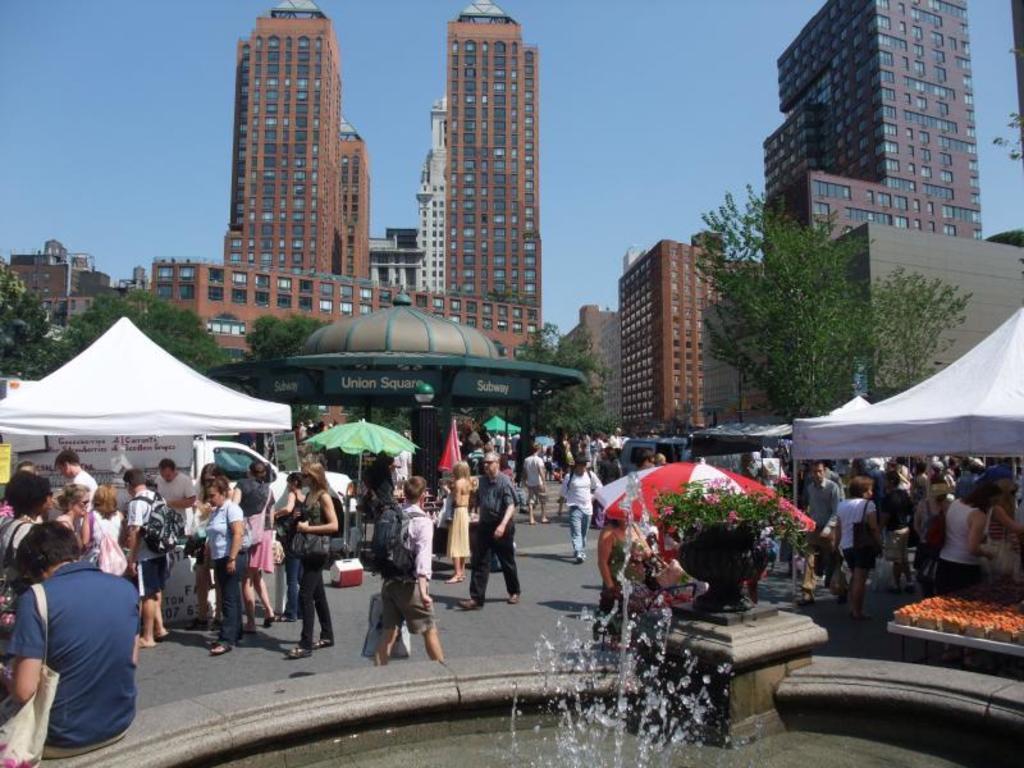Could you give a brief overview of what you see in this image? In this image there are buildings and trees. We can see tents. At the bottom there are people and we can see a fountain. In the background there is sky and we can see a car. 